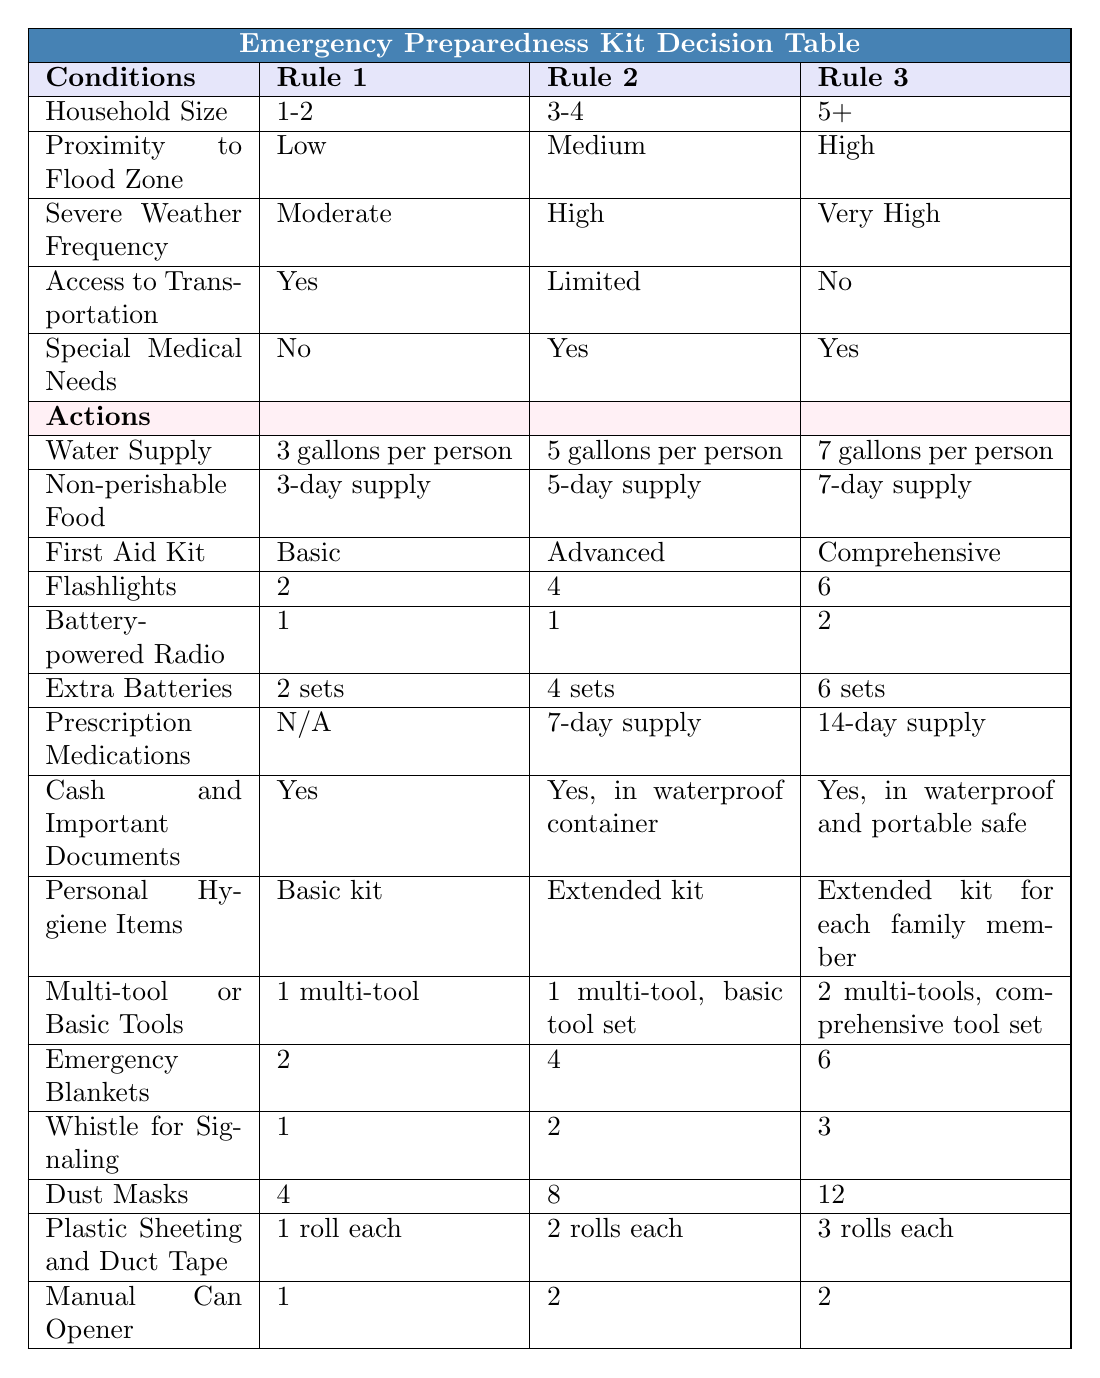What is the recommended water supply for a household of 5 or more people in a high flood zone? According to the table, for a household size of 5+ in a high flood zone, the recommended water supply is 7 gallons per person.
Answer: 7 gallons per person How many total flashlights should a household of 3-4 people with special medical needs prepare? The table indicates that for a household size of 3-4 with special medical needs, 4 flashlights are recommended.
Answer: 4 Is a first aid kit included for a household of 1-2 people with limited access to transportation? The table shows that for a household size of 1-2 with limited access to transportation, a basic first aid kit is suggested, which confirms that a first aid kit is included.
Answer: Yes What is the total amount of dust masks recommended for a household of 5 or more people with special medical needs? Based on the table, for a household size of 5+ with special medical needs, 12 dust masks are recommended.
Answer: 12 What is the difference in the number of emergency blankets recommended for a household of 3-4 people versus a household of 1-2 people? According to the table, a household of 3-4 people is recommended to have 4 emergency blankets while a household of 1-2 people is suggested to have 2. The difference is calculated as 4 - 2 = 2.
Answer: 2 Are prescription medications necessary for all household sizes in a low flood zone? The table indicates that prescription medications are not applicable (N/A) for a household of 1-2 in a low flood zone, meaning they are not necessary for all sizes.
Answer: No What is the total number of items that a household of 3-4 people with high severe weather frequency should prepare, including food, water, and personal hygiene items? From the table, a household of 3-4 should prepare a 5-day supply of non-perishable food, 5 gallons of water per person, and an extended kit for personal hygiene.  For 4 people, the total is 5 (non-perishable food days) + 20 (5 gallons x 4 people) + 1 (extended kit) = 26 items.
Answer: 26 How many additional sets of extra batteries are recommended for a household of 5 or more compared to a household of 3-4? The table shows that a household of 5+ needs 6 sets of extra batteries and a household of 3-4 needs 4 sets. The additional number of sets is 6 - 4 = 2.
Answer: 2 What should a household of 1-2 people include concerning cash and important documents? The table indicates that a household of 1-2 people should include cash and important documents without any specific requirement, so they should prepare a basic arrangement.
Answer: Yes 